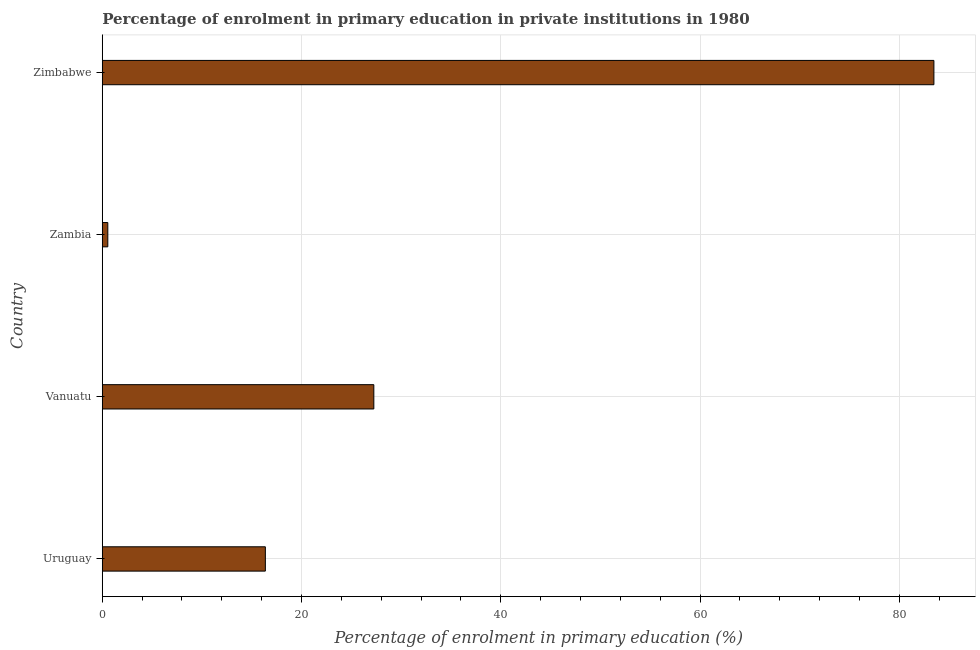Does the graph contain any zero values?
Provide a short and direct response. No. Does the graph contain grids?
Offer a very short reply. Yes. What is the title of the graph?
Give a very brief answer. Percentage of enrolment in primary education in private institutions in 1980. What is the label or title of the X-axis?
Ensure brevity in your answer.  Percentage of enrolment in primary education (%). What is the enrolment percentage in primary education in Zimbabwe?
Ensure brevity in your answer.  83.47. Across all countries, what is the maximum enrolment percentage in primary education?
Make the answer very short. 83.47. Across all countries, what is the minimum enrolment percentage in primary education?
Provide a short and direct response. 0.56. In which country was the enrolment percentage in primary education maximum?
Provide a succinct answer. Zimbabwe. In which country was the enrolment percentage in primary education minimum?
Give a very brief answer. Zambia. What is the sum of the enrolment percentage in primary education?
Your answer should be very brief. 127.65. What is the difference between the enrolment percentage in primary education in Uruguay and Zambia?
Your response must be concise. 15.81. What is the average enrolment percentage in primary education per country?
Make the answer very short. 31.91. What is the median enrolment percentage in primary education?
Ensure brevity in your answer.  21.81. In how many countries, is the enrolment percentage in primary education greater than 20 %?
Provide a short and direct response. 2. What is the ratio of the enrolment percentage in primary education in Uruguay to that in Vanuatu?
Provide a succinct answer. 0.6. Is the enrolment percentage in primary education in Vanuatu less than that in Zambia?
Provide a succinct answer. No. Is the difference between the enrolment percentage in primary education in Zambia and Zimbabwe greater than the difference between any two countries?
Provide a short and direct response. Yes. What is the difference between the highest and the second highest enrolment percentage in primary education?
Give a very brief answer. 56.21. Is the sum of the enrolment percentage in primary education in Uruguay and Zimbabwe greater than the maximum enrolment percentage in primary education across all countries?
Keep it short and to the point. Yes. What is the difference between the highest and the lowest enrolment percentage in primary education?
Offer a terse response. 82.91. Are all the bars in the graph horizontal?
Make the answer very short. Yes. Are the values on the major ticks of X-axis written in scientific E-notation?
Give a very brief answer. No. What is the Percentage of enrolment in primary education (%) in Uruguay?
Provide a short and direct response. 16.37. What is the Percentage of enrolment in primary education (%) in Vanuatu?
Keep it short and to the point. 27.26. What is the Percentage of enrolment in primary education (%) of Zambia?
Offer a terse response. 0.56. What is the Percentage of enrolment in primary education (%) of Zimbabwe?
Give a very brief answer. 83.47. What is the difference between the Percentage of enrolment in primary education (%) in Uruguay and Vanuatu?
Offer a very short reply. -10.89. What is the difference between the Percentage of enrolment in primary education (%) in Uruguay and Zambia?
Give a very brief answer. 15.81. What is the difference between the Percentage of enrolment in primary education (%) in Uruguay and Zimbabwe?
Offer a terse response. -67.1. What is the difference between the Percentage of enrolment in primary education (%) in Vanuatu and Zambia?
Your response must be concise. 26.7. What is the difference between the Percentage of enrolment in primary education (%) in Vanuatu and Zimbabwe?
Offer a terse response. -56.21. What is the difference between the Percentage of enrolment in primary education (%) in Zambia and Zimbabwe?
Your answer should be compact. -82.91. What is the ratio of the Percentage of enrolment in primary education (%) in Uruguay to that in Vanuatu?
Make the answer very short. 0.6. What is the ratio of the Percentage of enrolment in primary education (%) in Uruguay to that in Zambia?
Give a very brief answer. 29.31. What is the ratio of the Percentage of enrolment in primary education (%) in Uruguay to that in Zimbabwe?
Your answer should be compact. 0.2. What is the ratio of the Percentage of enrolment in primary education (%) in Vanuatu to that in Zambia?
Offer a very short reply. 48.8. What is the ratio of the Percentage of enrolment in primary education (%) in Vanuatu to that in Zimbabwe?
Make the answer very short. 0.33. What is the ratio of the Percentage of enrolment in primary education (%) in Zambia to that in Zimbabwe?
Provide a succinct answer. 0.01. 